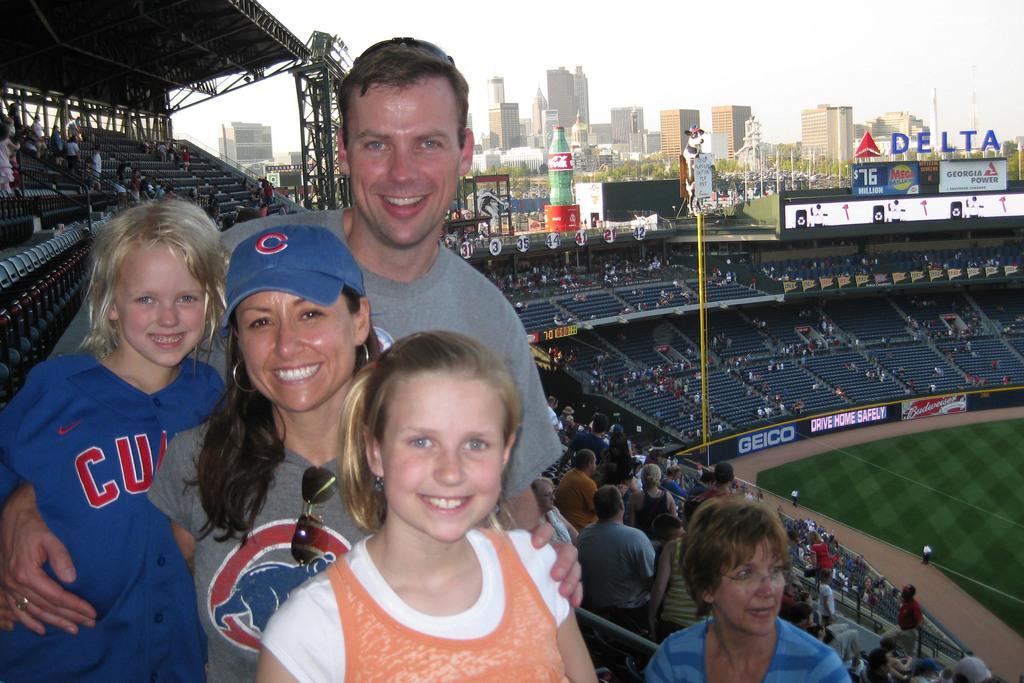Please provide a concise description of this image. In the center of the image we can see group of persons standing. In the background we can see stadium, grass, crowd, chairs, name boards, statue, building, trees and sky. 